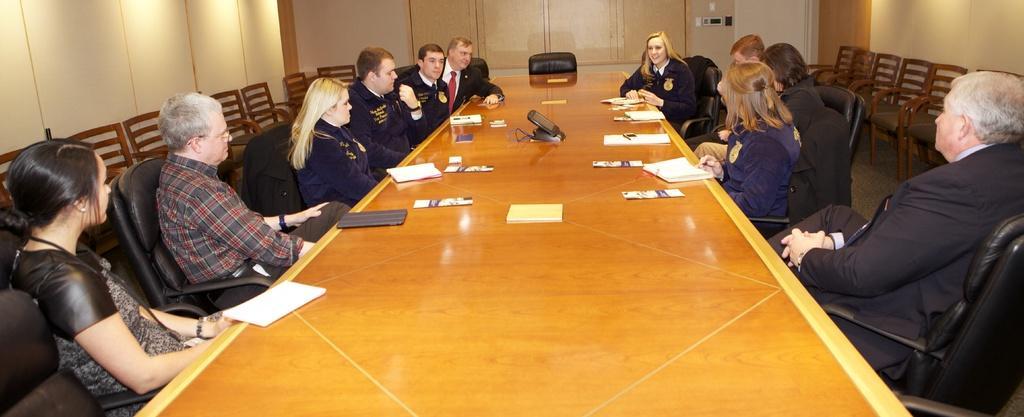In one or two sentences, can you explain what this image depicts? In this picture we can see some people are sitting on chairs in front of a table, there are some books and a screen present on the table, on the right side and left side there are chairs, it looks like a wall in the background. 